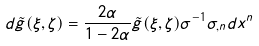Convert formula to latex. <formula><loc_0><loc_0><loc_500><loc_500>d \tilde { g } ( \xi , \zeta ) = \frac { 2 \alpha } { 1 - 2 \alpha } \tilde { g } ( \xi , \zeta ) \sigma ^ { - 1 } \sigma _ { , n } d x ^ { n }</formula> 